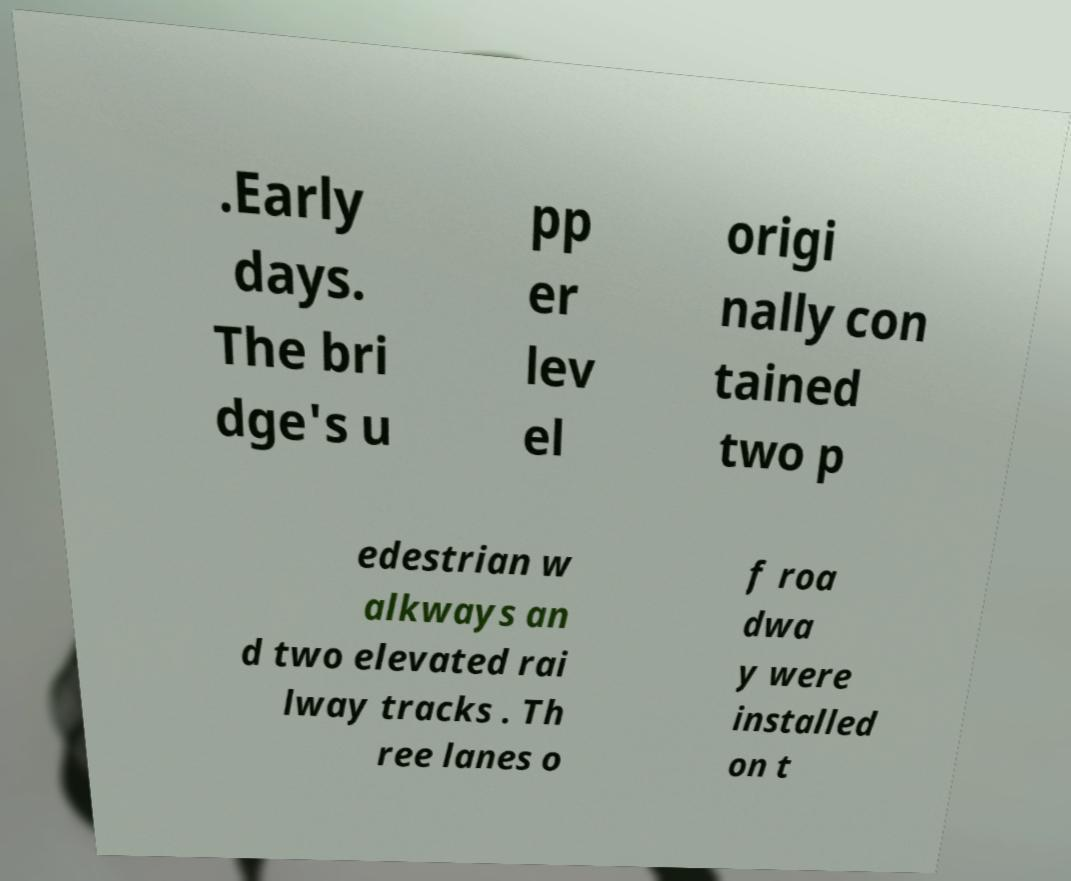Please identify and transcribe the text found in this image. .Early days. The bri dge's u pp er lev el origi nally con tained two p edestrian w alkways an d two elevated rai lway tracks . Th ree lanes o f roa dwa y were installed on t 